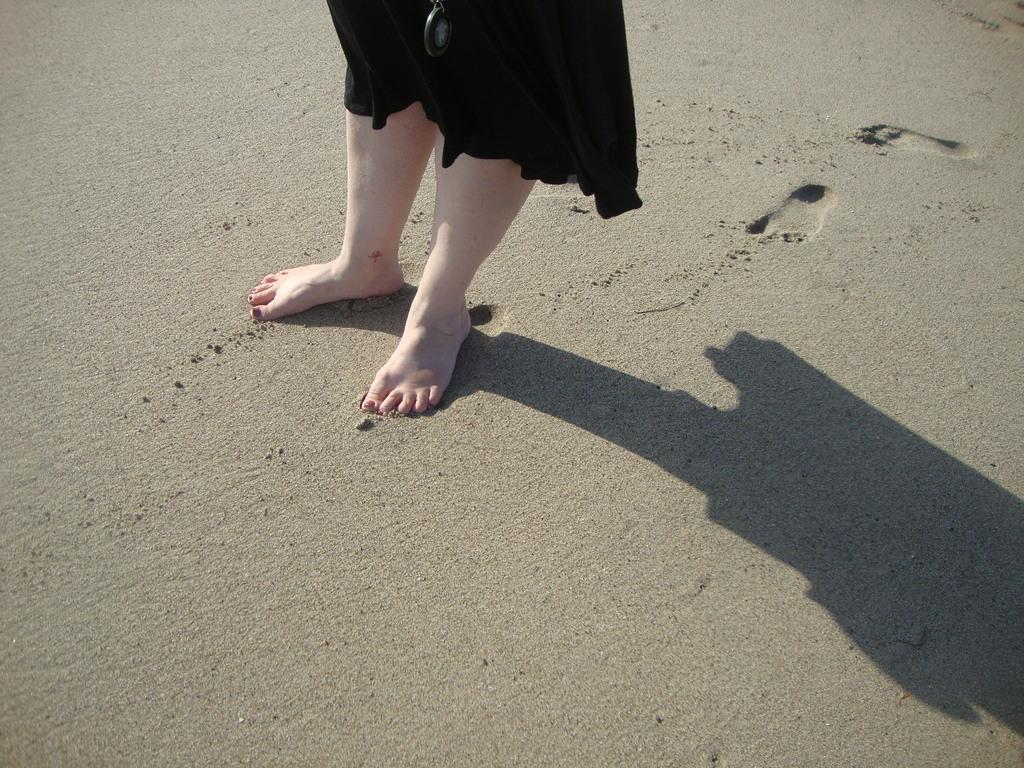What part of a person can be seen in the image? There are legs of a person visible in the image. Where are the legs located? The legs are on the sand. What evidence of the person's presence can be seen in the image? There are footprints in the image. What else is visible in the image besides the person's legs and footprints? There is a shadow in the image. What type of government is depicted in the image? There is no government depicted in the image; it only shows a person's legs, sand, footprints, and a shadow. 